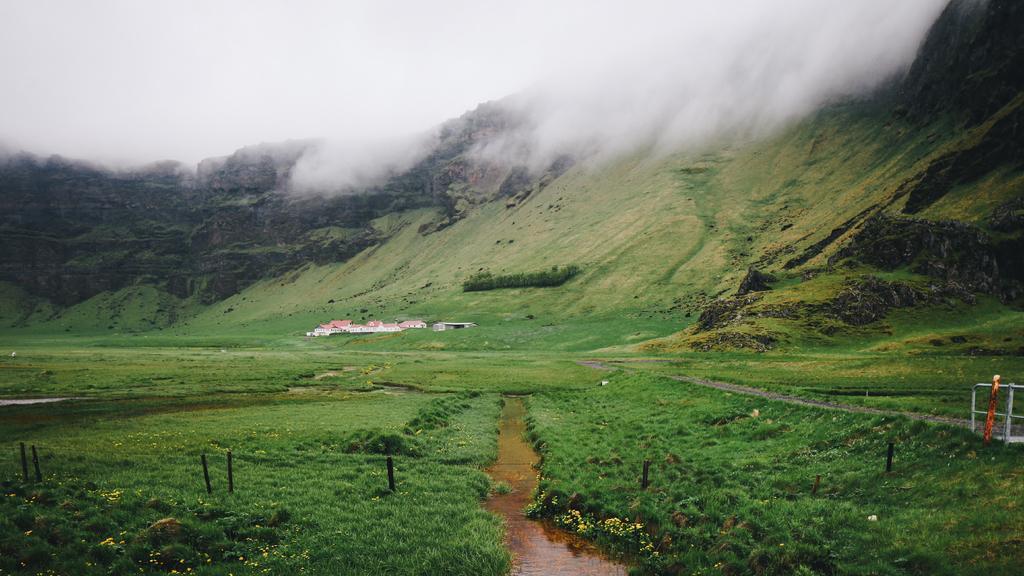Please provide a concise description of this image. In the center of the image we can see the sky, smoky, hills, grass, buildings, water and plants with flowers. On the right side of the image, there is a fence and one object. 